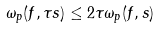<formula> <loc_0><loc_0><loc_500><loc_500>\omega _ { p } ( f , \tau s ) \leq 2 \tau \omega _ { p } ( f , s )</formula> 